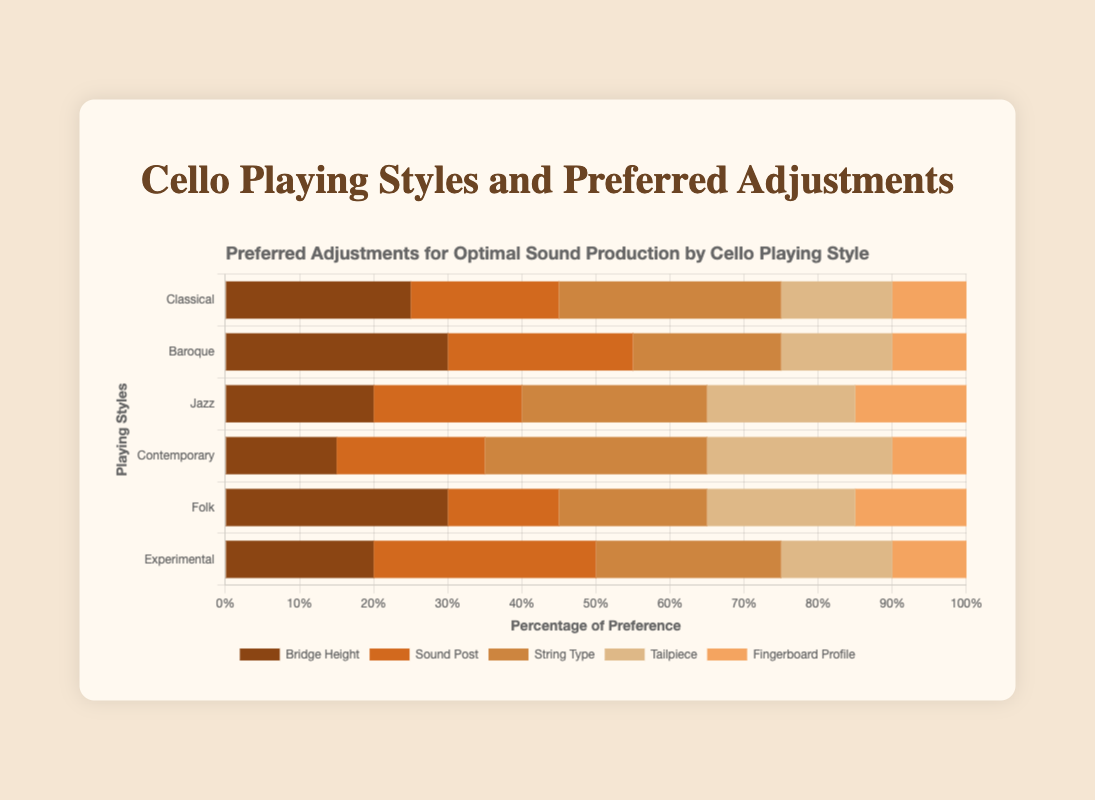Which playing style has the highest preference for Bridge Height adjustments? Look for the largest value in the 'Bridge Height' section of the horizontal bars. The value for 'Bridge Height' is highest at 30% in both 'Baroque' and 'Folk.'
Answer: Baroque and Folk What is the combined preference percentage for String Type and Tailpiece in the Classical style? Add the percentages for 'String Type' and 'Tailpiece' within the 'Classical' style bar. String Type is 30% and Tailpiece is 15%. Thus, 30% + 15% = 45%.
Answer: 45% Compare the Sound Post adjustments between Baroque and Experimental styles. Which one has a higher preference? Check the 'Sound Post' section in both the 'Baroque' and 'Experimental' bars. Baroque has 25% and Experimental has 30%. Thus, Experimental has a higher preference.
Answer: Experimental How does the preference for Fingerboard Profile in Jazz compare to Contemporary? Look at the 'Fingerboard Profile' section in both 'Jazz' and 'Contemporary' bars. Jazz has 15% while Contemporary has 10%. Thus, Jazz has a higher preference.
Answer: Jazz In which playing style is the preference for Tailpiece adjustments the highest? Look for the highest value in the 'Tailpiece' section across all bars. The highest value is 25% in the 'Contemporary' style.
Answer: Contemporary Which playing style favors the use of the Sound Post the least? Look for the smallest value in the 'Sound Post' section across all bars. The smallest value is 15% in the 'Folk' style.
Answer: Folk What is the total preference percentage for all adjustments combined in the Experimental style? Sum up all values for adjustments in the 'Experimental' style. 20% (Bridge Height) + 30% (Sound Post) + 25% (String Type) + 15% (Tailpiece) + 10% (Fingerboard Profile) = 100%.
Answer: 100% Which adjustment has the most consistent preference (minimal variability) across the playing styles? Visually assess the differences in heights for each adjustment type across all styles. 'Fingerboard Profile' shows minimal variability with values around 10-15% across all styles.
Answer: Fingerboard Profile Is the preference for String Type adjustments higher in Contemporary or Classical style? Compare the 'String Type' section in 'Contemporary' and 'Classical'. Contemporary has 30% while Classical also has 30%. Therefore, both have equal preference.
Answer: Equal 